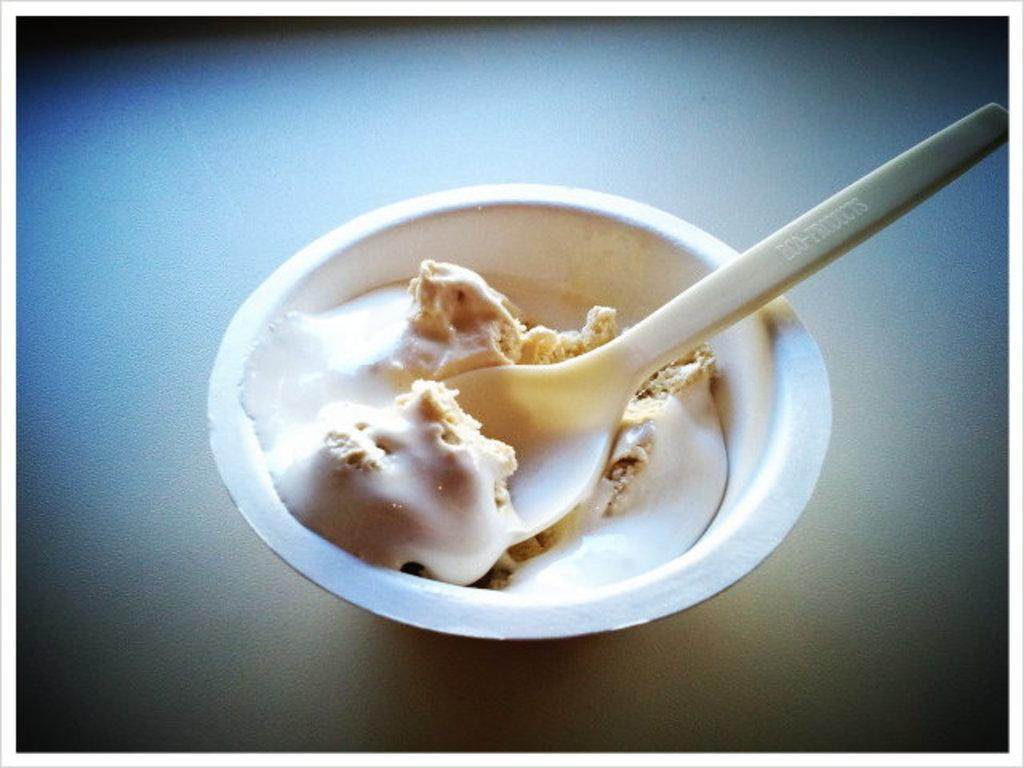What is the main piece of furniture in the image? There is a table in the image. What is placed on the table? There is an ice cream cup on the table. What utensil is present in the image? There is a spoon present in the image. What type of sand can be seen on the beach in the image? There is no beach or sand present in the image; it features a table with an ice cream cup and a spoon. 